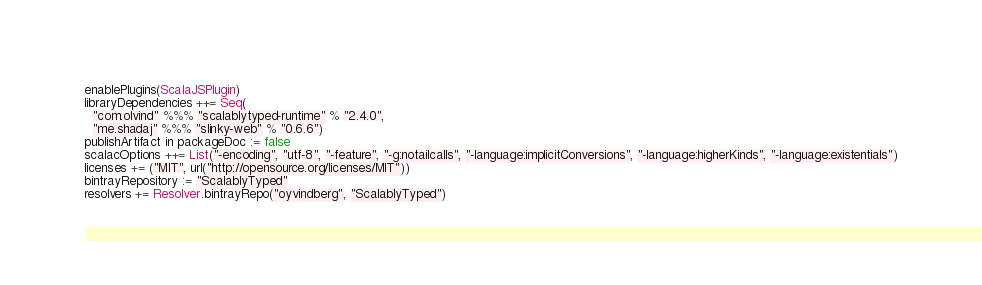Convert code to text. <code><loc_0><loc_0><loc_500><loc_500><_Scala_>enablePlugins(ScalaJSPlugin)
libraryDependencies ++= Seq(
  "com.olvind" %%% "scalablytyped-runtime" % "2.4.0",
  "me.shadaj" %%% "slinky-web" % "0.6.6")
publishArtifact in packageDoc := false
scalacOptions ++= List("-encoding", "utf-8", "-feature", "-g:notailcalls", "-language:implicitConversions", "-language:higherKinds", "-language:existentials")
licenses += ("MIT", url("http://opensource.org/licenses/MIT"))
bintrayRepository := "ScalablyTyped"
resolvers += Resolver.bintrayRepo("oyvindberg", "ScalablyTyped")
</code> 